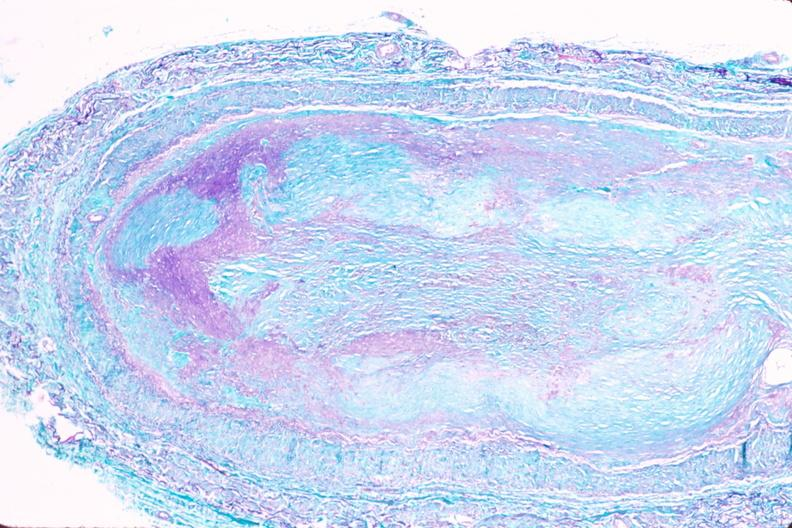s vasculature present?
Answer the question using a single word or phrase. Yes 